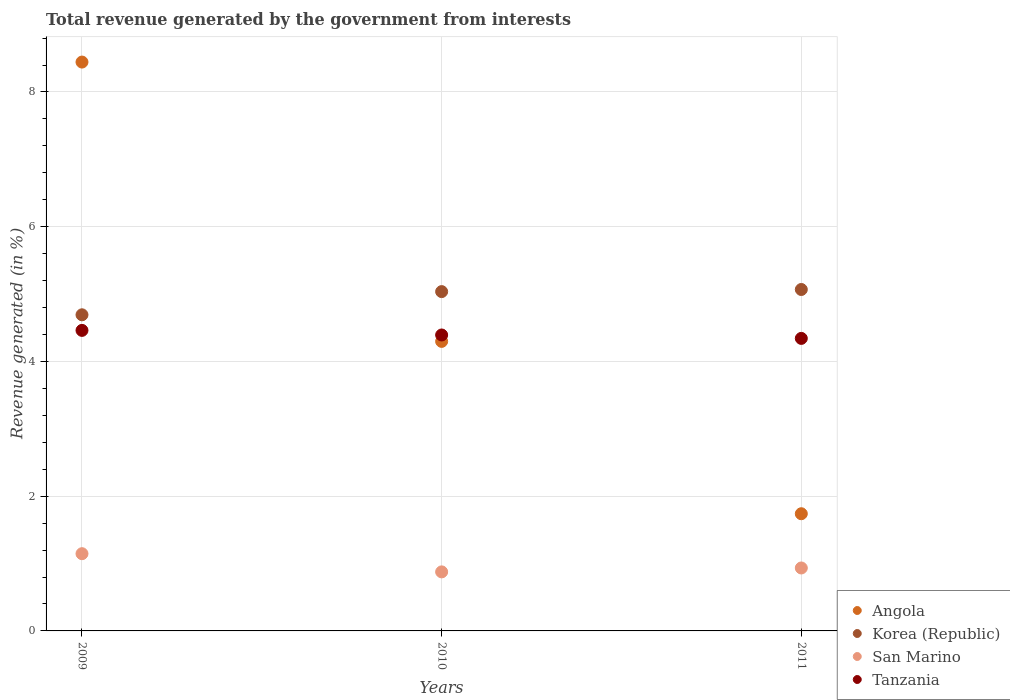Is the number of dotlines equal to the number of legend labels?
Provide a short and direct response. Yes. What is the total revenue generated in San Marino in 2009?
Your answer should be compact. 1.15. Across all years, what is the maximum total revenue generated in Angola?
Offer a very short reply. 8.44. Across all years, what is the minimum total revenue generated in Angola?
Ensure brevity in your answer.  1.74. What is the total total revenue generated in Korea (Republic) in the graph?
Make the answer very short. 14.8. What is the difference between the total revenue generated in Angola in 2010 and that in 2011?
Provide a succinct answer. 2.56. What is the difference between the total revenue generated in Angola in 2011 and the total revenue generated in Korea (Republic) in 2010?
Offer a very short reply. -3.3. What is the average total revenue generated in Angola per year?
Provide a succinct answer. 4.83. In the year 2009, what is the difference between the total revenue generated in Angola and total revenue generated in Tanzania?
Give a very brief answer. 3.98. In how many years, is the total revenue generated in Tanzania greater than 7.2 %?
Your answer should be compact. 0. What is the ratio of the total revenue generated in Korea (Republic) in 2010 to that in 2011?
Give a very brief answer. 0.99. Is the total revenue generated in Korea (Republic) in 2009 less than that in 2010?
Your response must be concise. Yes. Is the difference between the total revenue generated in Angola in 2010 and 2011 greater than the difference between the total revenue generated in Tanzania in 2010 and 2011?
Your answer should be very brief. Yes. What is the difference between the highest and the second highest total revenue generated in San Marino?
Give a very brief answer. 0.21. What is the difference between the highest and the lowest total revenue generated in Angola?
Offer a very short reply. 6.7. In how many years, is the total revenue generated in Tanzania greater than the average total revenue generated in Tanzania taken over all years?
Keep it short and to the point. 1. Is it the case that in every year, the sum of the total revenue generated in San Marino and total revenue generated in Tanzania  is greater than the sum of total revenue generated in Korea (Republic) and total revenue generated in Angola?
Provide a succinct answer. No. Is it the case that in every year, the sum of the total revenue generated in San Marino and total revenue generated in Angola  is greater than the total revenue generated in Korea (Republic)?
Your answer should be compact. No. Is the total revenue generated in San Marino strictly greater than the total revenue generated in Korea (Republic) over the years?
Keep it short and to the point. No. How many dotlines are there?
Your answer should be compact. 4. How many years are there in the graph?
Your answer should be very brief. 3. What is the difference between two consecutive major ticks on the Y-axis?
Make the answer very short. 2. Does the graph contain any zero values?
Your answer should be compact. No. Where does the legend appear in the graph?
Keep it short and to the point. Bottom right. How many legend labels are there?
Your answer should be very brief. 4. How are the legend labels stacked?
Keep it short and to the point. Vertical. What is the title of the graph?
Your answer should be very brief. Total revenue generated by the government from interests. What is the label or title of the X-axis?
Offer a very short reply. Years. What is the label or title of the Y-axis?
Give a very brief answer. Revenue generated (in %). What is the Revenue generated (in %) of Angola in 2009?
Offer a very short reply. 8.44. What is the Revenue generated (in %) in Korea (Republic) in 2009?
Provide a short and direct response. 4.69. What is the Revenue generated (in %) in San Marino in 2009?
Offer a terse response. 1.15. What is the Revenue generated (in %) in Tanzania in 2009?
Provide a succinct answer. 4.46. What is the Revenue generated (in %) in Angola in 2010?
Keep it short and to the point. 4.3. What is the Revenue generated (in %) of Korea (Republic) in 2010?
Your answer should be very brief. 5.04. What is the Revenue generated (in %) in San Marino in 2010?
Offer a very short reply. 0.88. What is the Revenue generated (in %) of Tanzania in 2010?
Your answer should be compact. 4.39. What is the Revenue generated (in %) in Angola in 2011?
Offer a terse response. 1.74. What is the Revenue generated (in %) in Korea (Republic) in 2011?
Make the answer very short. 5.07. What is the Revenue generated (in %) of San Marino in 2011?
Make the answer very short. 0.93. What is the Revenue generated (in %) in Tanzania in 2011?
Provide a short and direct response. 4.34. Across all years, what is the maximum Revenue generated (in %) in Angola?
Ensure brevity in your answer.  8.44. Across all years, what is the maximum Revenue generated (in %) in Korea (Republic)?
Make the answer very short. 5.07. Across all years, what is the maximum Revenue generated (in %) in San Marino?
Provide a short and direct response. 1.15. Across all years, what is the maximum Revenue generated (in %) in Tanzania?
Offer a very short reply. 4.46. Across all years, what is the minimum Revenue generated (in %) of Angola?
Your answer should be very brief. 1.74. Across all years, what is the minimum Revenue generated (in %) in Korea (Republic)?
Provide a short and direct response. 4.69. Across all years, what is the minimum Revenue generated (in %) of San Marino?
Offer a terse response. 0.88. Across all years, what is the minimum Revenue generated (in %) in Tanzania?
Provide a succinct answer. 4.34. What is the total Revenue generated (in %) of Angola in the graph?
Your answer should be very brief. 14.48. What is the total Revenue generated (in %) of Korea (Republic) in the graph?
Your answer should be compact. 14.8. What is the total Revenue generated (in %) of San Marino in the graph?
Your response must be concise. 2.96. What is the total Revenue generated (in %) in Tanzania in the graph?
Keep it short and to the point. 13.2. What is the difference between the Revenue generated (in %) of Angola in 2009 and that in 2010?
Make the answer very short. 4.15. What is the difference between the Revenue generated (in %) of Korea (Republic) in 2009 and that in 2010?
Your response must be concise. -0.34. What is the difference between the Revenue generated (in %) in San Marino in 2009 and that in 2010?
Offer a terse response. 0.27. What is the difference between the Revenue generated (in %) in Tanzania in 2009 and that in 2010?
Offer a very short reply. 0.07. What is the difference between the Revenue generated (in %) of Angola in 2009 and that in 2011?
Your answer should be very brief. 6.7. What is the difference between the Revenue generated (in %) in Korea (Republic) in 2009 and that in 2011?
Your answer should be compact. -0.38. What is the difference between the Revenue generated (in %) of San Marino in 2009 and that in 2011?
Your answer should be very brief. 0.21. What is the difference between the Revenue generated (in %) in Tanzania in 2009 and that in 2011?
Your answer should be very brief. 0.12. What is the difference between the Revenue generated (in %) of Angola in 2010 and that in 2011?
Your answer should be very brief. 2.56. What is the difference between the Revenue generated (in %) of Korea (Republic) in 2010 and that in 2011?
Keep it short and to the point. -0.03. What is the difference between the Revenue generated (in %) in San Marino in 2010 and that in 2011?
Give a very brief answer. -0.06. What is the difference between the Revenue generated (in %) in Tanzania in 2010 and that in 2011?
Make the answer very short. 0.05. What is the difference between the Revenue generated (in %) of Angola in 2009 and the Revenue generated (in %) of Korea (Republic) in 2010?
Your answer should be compact. 3.41. What is the difference between the Revenue generated (in %) of Angola in 2009 and the Revenue generated (in %) of San Marino in 2010?
Provide a short and direct response. 7.57. What is the difference between the Revenue generated (in %) in Angola in 2009 and the Revenue generated (in %) in Tanzania in 2010?
Your answer should be compact. 4.05. What is the difference between the Revenue generated (in %) in Korea (Republic) in 2009 and the Revenue generated (in %) in San Marino in 2010?
Your answer should be compact. 3.82. What is the difference between the Revenue generated (in %) in Korea (Republic) in 2009 and the Revenue generated (in %) in Tanzania in 2010?
Provide a succinct answer. 0.3. What is the difference between the Revenue generated (in %) of San Marino in 2009 and the Revenue generated (in %) of Tanzania in 2010?
Your response must be concise. -3.25. What is the difference between the Revenue generated (in %) in Angola in 2009 and the Revenue generated (in %) in Korea (Republic) in 2011?
Your response must be concise. 3.38. What is the difference between the Revenue generated (in %) in Angola in 2009 and the Revenue generated (in %) in San Marino in 2011?
Your answer should be compact. 7.51. What is the difference between the Revenue generated (in %) in Angola in 2009 and the Revenue generated (in %) in Tanzania in 2011?
Provide a short and direct response. 4.1. What is the difference between the Revenue generated (in %) of Korea (Republic) in 2009 and the Revenue generated (in %) of San Marino in 2011?
Give a very brief answer. 3.76. What is the difference between the Revenue generated (in %) of Korea (Republic) in 2009 and the Revenue generated (in %) of Tanzania in 2011?
Your answer should be compact. 0.35. What is the difference between the Revenue generated (in %) in San Marino in 2009 and the Revenue generated (in %) in Tanzania in 2011?
Provide a short and direct response. -3.2. What is the difference between the Revenue generated (in %) of Angola in 2010 and the Revenue generated (in %) of Korea (Republic) in 2011?
Offer a terse response. -0.77. What is the difference between the Revenue generated (in %) of Angola in 2010 and the Revenue generated (in %) of San Marino in 2011?
Provide a short and direct response. 3.36. What is the difference between the Revenue generated (in %) in Angola in 2010 and the Revenue generated (in %) in Tanzania in 2011?
Your answer should be very brief. -0.04. What is the difference between the Revenue generated (in %) in Korea (Republic) in 2010 and the Revenue generated (in %) in San Marino in 2011?
Your answer should be very brief. 4.1. What is the difference between the Revenue generated (in %) in Korea (Republic) in 2010 and the Revenue generated (in %) in Tanzania in 2011?
Offer a very short reply. 0.69. What is the difference between the Revenue generated (in %) of San Marino in 2010 and the Revenue generated (in %) of Tanzania in 2011?
Ensure brevity in your answer.  -3.47. What is the average Revenue generated (in %) of Angola per year?
Your response must be concise. 4.83. What is the average Revenue generated (in %) of Korea (Republic) per year?
Give a very brief answer. 4.93. What is the average Revenue generated (in %) of San Marino per year?
Keep it short and to the point. 0.99. What is the average Revenue generated (in %) in Tanzania per year?
Your answer should be very brief. 4.4. In the year 2009, what is the difference between the Revenue generated (in %) of Angola and Revenue generated (in %) of Korea (Republic)?
Provide a short and direct response. 3.75. In the year 2009, what is the difference between the Revenue generated (in %) of Angola and Revenue generated (in %) of San Marino?
Give a very brief answer. 7.3. In the year 2009, what is the difference between the Revenue generated (in %) of Angola and Revenue generated (in %) of Tanzania?
Keep it short and to the point. 3.98. In the year 2009, what is the difference between the Revenue generated (in %) of Korea (Republic) and Revenue generated (in %) of San Marino?
Provide a succinct answer. 3.55. In the year 2009, what is the difference between the Revenue generated (in %) in Korea (Republic) and Revenue generated (in %) in Tanzania?
Your answer should be very brief. 0.23. In the year 2009, what is the difference between the Revenue generated (in %) of San Marino and Revenue generated (in %) of Tanzania?
Give a very brief answer. -3.31. In the year 2010, what is the difference between the Revenue generated (in %) of Angola and Revenue generated (in %) of Korea (Republic)?
Your answer should be very brief. -0.74. In the year 2010, what is the difference between the Revenue generated (in %) of Angola and Revenue generated (in %) of San Marino?
Offer a terse response. 3.42. In the year 2010, what is the difference between the Revenue generated (in %) in Angola and Revenue generated (in %) in Tanzania?
Offer a terse response. -0.1. In the year 2010, what is the difference between the Revenue generated (in %) of Korea (Republic) and Revenue generated (in %) of San Marino?
Make the answer very short. 4.16. In the year 2010, what is the difference between the Revenue generated (in %) in Korea (Republic) and Revenue generated (in %) in Tanzania?
Your answer should be compact. 0.64. In the year 2010, what is the difference between the Revenue generated (in %) in San Marino and Revenue generated (in %) in Tanzania?
Make the answer very short. -3.52. In the year 2011, what is the difference between the Revenue generated (in %) in Angola and Revenue generated (in %) in Korea (Republic)?
Provide a succinct answer. -3.33. In the year 2011, what is the difference between the Revenue generated (in %) in Angola and Revenue generated (in %) in San Marino?
Keep it short and to the point. 0.81. In the year 2011, what is the difference between the Revenue generated (in %) of Angola and Revenue generated (in %) of Tanzania?
Provide a succinct answer. -2.6. In the year 2011, what is the difference between the Revenue generated (in %) in Korea (Republic) and Revenue generated (in %) in San Marino?
Offer a very short reply. 4.13. In the year 2011, what is the difference between the Revenue generated (in %) in Korea (Republic) and Revenue generated (in %) in Tanzania?
Keep it short and to the point. 0.73. In the year 2011, what is the difference between the Revenue generated (in %) in San Marino and Revenue generated (in %) in Tanzania?
Your answer should be very brief. -3.41. What is the ratio of the Revenue generated (in %) in Angola in 2009 to that in 2010?
Offer a terse response. 1.96. What is the ratio of the Revenue generated (in %) of Korea (Republic) in 2009 to that in 2010?
Offer a very short reply. 0.93. What is the ratio of the Revenue generated (in %) of San Marino in 2009 to that in 2010?
Keep it short and to the point. 1.31. What is the ratio of the Revenue generated (in %) of Tanzania in 2009 to that in 2010?
Give a very brief answer. 1.02. What is the ratio of the Revenue generated (in %) of Angola in 2009 to that in 2011?
Make the answer very short. 4.85. What is the ratio of the Revenue generated (in %) of Korea (Republic) in 2009 to that in 2011?
Make the answer very short. 0.93. What is the ratio of the Revenue generated (in %) of San Marino in 2009 to that in 2011?
Your response must be concise. 1.23. What is the ratio of the Revenue generated (in %) of Tanzania in 2009 to that in 2011?
Give a very brief answer. 1.03. What is the ratio of the Revenue generated (in %) of Angola in 2010 to that in 2011?
Your answer should be very brief. 2.47. What is the ratio of the Revenue generated (in %) in Korea (Republic) in 2010 to that in 2011?
Provide a short and direct response. 0.99. What is the ratio of the Revenue generated (in %) in San Marino in 2010 to that in 2011?
Give a very brief answer. 0.94. What is the ratio of the Revenue generated (in %) of Tanzania in 2010 to that in 2011?
Your response must be concise. 1.01. What is the difference between the highest and the second highest Revenue generated (in %) of Angola?
Provide a short and direct response. 4.15. What is the difference between the highest and the second highest Revenue generated (in %) in Korea (Republic)?
Your response must be concise. 0.03. What is the difference between the highest and the second highest Revenue generated (in %) of San Marino?
Provide a succinct answer. 0.21. What is the difference between the highest and the second highest Revenue generated (in %) of Tanzania?
Offer a terse response. 0.07. What is the difference between the highest and the lowest Revenue generated (in %) of Angola?
Your response must be concise. 6.7. What is the difference between the highest and the lowest Revenue generated (in %) in Korea (Republic)?
Your response must be concise. 0.38. What is the difference between the highest and the lowest Revenue generated (in %) of San Marino?
Make the answer very short. 0.27. What is the difference between the highest and the lowest Revenue generated (in %) in Tanzania?
Your answer should be compact. 0.12. 